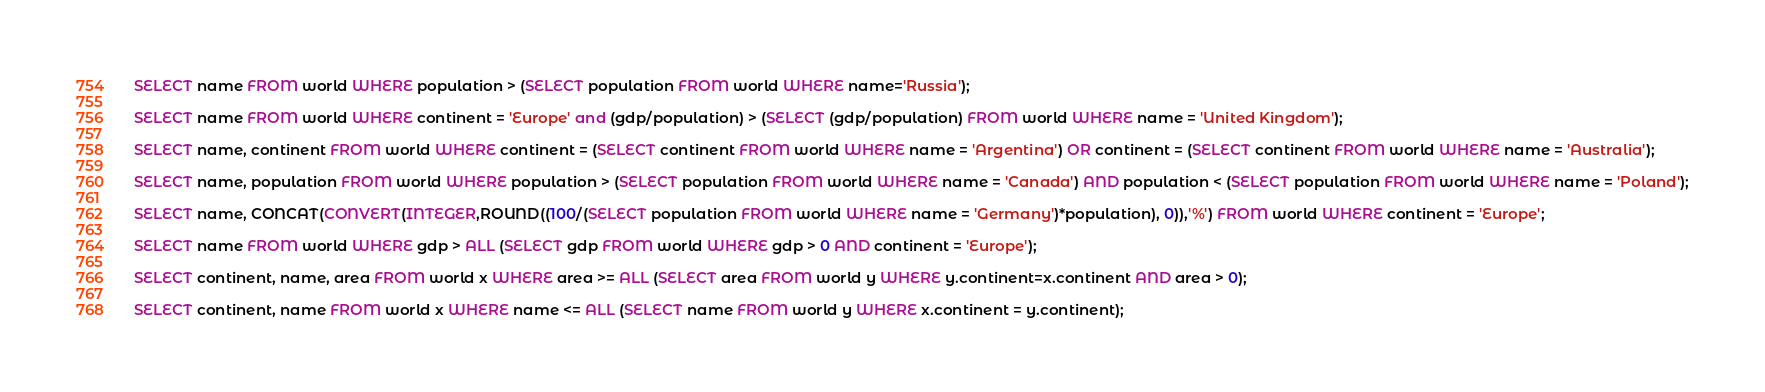<code> <loc_0><loc_0><loc_500><loc_500><_SQL_>SELECT name FROM world WHERE population > (SELECT population FROM world WHERE name='Russia');

SELECT name FROM world WHERE continent = 'Europe' and (gdp/population) > (SELECT (gdp/population) FROM world WHERE name = 'United Kingdom');

SELECT name, continent FROM world WHERE continent = (SELECT continent FROM world WHERE name = 'Argentina') OR continent = (SELECT continent FROM world WHERE name = 'Australia');

SELECT name, population FROM world WHERE population > (SELECT population FROM world WHERE name = 'Canada') AND population < (SELECT population FROM world WHERE name = 'Poland');

SELECT name, CONCAT(CONVERT(INTEGER,ROUND((100/(SELECT population FROM world WHERE name = 'Germany')*population), 0)),'%') FROM world WHERE continent = 'Europe';

SELECT name FROM world WHERE gdp > ALL (SELECT gdp FROM world WHERE gdp > 0 AND continent = 'Europe');

SELECT continent, name, area FROM world x WHERE area >= ALL (SELECT area FROM world y WHERE y.continent=x.continent AND area > 0);

SELECT continent, name FROM world x WHERE name <= ALL (SELECT name FROM world y WHERE x.continent = y.continent);
</code> 